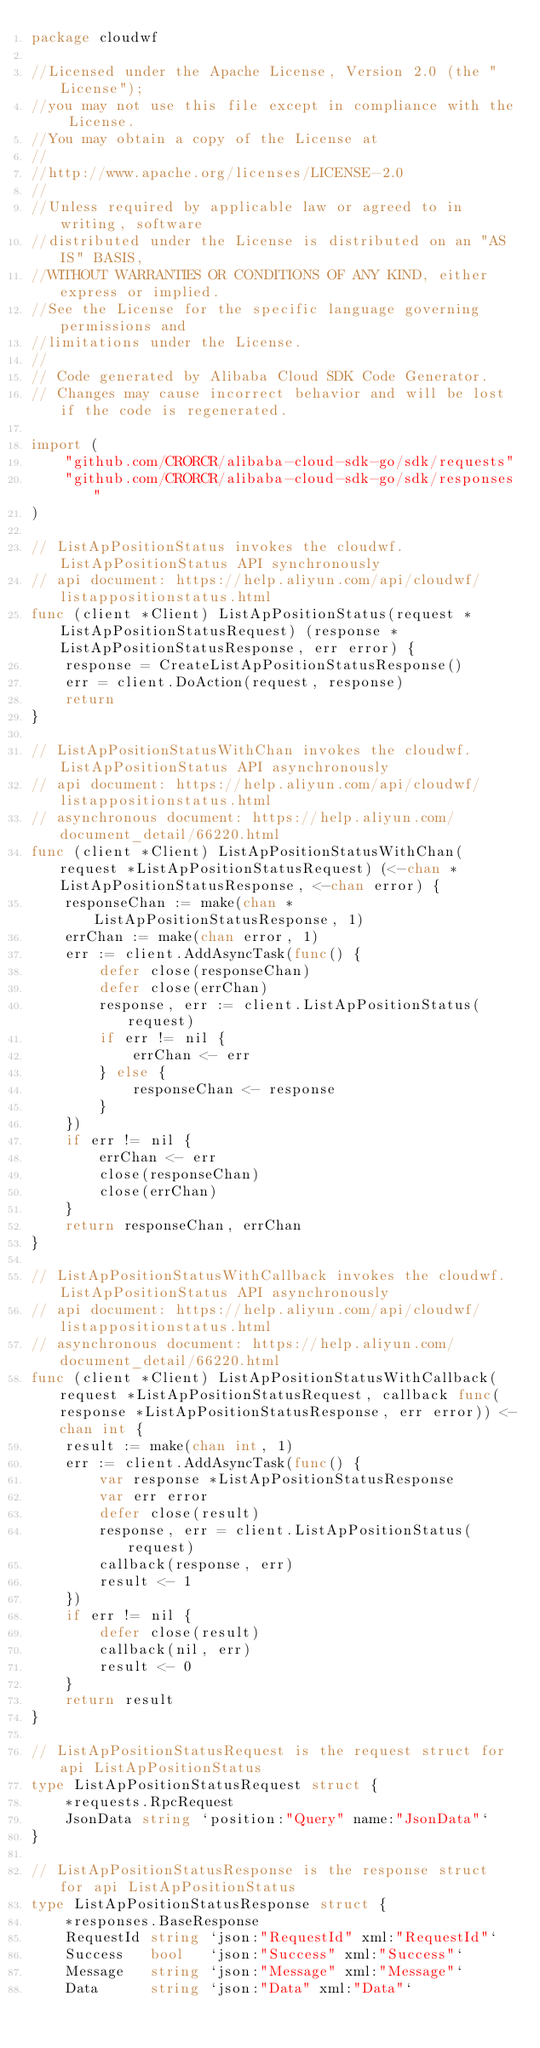<code> <loc_0><loc_0><loc_500><loc_500><_Go_>package cloudwf

//Licensed under the Apache License, Version 2.0 (the "License");
//you may not use this file except in compliance with the License.
//You may obtain a copy of the License at
//
//http://www.apache.org/licenses/LICENSE-2.0
//
//Unless required by applicable law or agreed to in writing, software
//distributed under the License is distributed on an "AS IS" BASIS,
//WITHOUT WARRANTIES OR CONDITIONS OF ANY KIND, either express or implied.
//See the License for the specific language governing permissions and
//limitations under the License.
//
// Code generated by Alibaba Cloud SDK Code Generator.
// Changes may cause incorrect behavior and will be lost if the code is regenerated.

import (
	"github.com/CRORCR/alibaba-cloud-sdk-go/sdk/requests"
	"github.com/CRORCR/alibaba-cloud-sdk-go/sdk/responses"
)

// ListApPositionStatus invokes the cloudwf.ListApPositionStatus API synchronously
// api document: https://help.aliyun.com/api/cloudwf/listappositionstatus.html
func (client *Client) ListApPositionStatus(request *ListApPositionStatusRequest) (response *ListApPositionStatusResponse, err error) {
	response = CreateListApPositionStatusResponse()
	err = client.DoAction(request, response)
	return
}

// ListApPositionStatusWithChan invokes the cloudwf.ListApPositionStatus API asynchronously
// api document: https://help.aliyun.com/api/cloudwf/listappositionstatus.html
// asynchronous document: https://help.aliyun.com/document_detail/66220.html
func (client *Client) ListApPositionStatusWithChan(request *ListApPositionStatusRequest) (<-chan *ListApPositionStatusResponse, <-chan error) {
	responseChan := make(chan *ListApPositionStatusResponse, 1)
	errChan := make(chan error, 1)
	err := client.AddAsyncTask(func() {
		defer close(responseChan)
		defer close(errChan)
		response, err := client.ListApPositionStatus(request)
		if err != nil {
			errChan <- err
		} else {
			responseChan <- response
		}
	})
	if err != nil {
		errChan <- err
		close(responseChan)
		close(errChan)
	}
	return responseChan, errChan
}

// ListApPositionStatusWithCallback invokes the cloudwf.ListApPositionStatus API asynchronously
// api document: https://help.aliyun.com/api/cloudwf/listappositionstatus.html
// asynchronous document: https://help.aliyun.com/document_detail/66220.html
func (client *Client) ListApPositionStatusWithCallback(request *ListApPositionStatusRequest, callback func(response *ListApPositionStatusResponse, err error)) <-chan int {
	result := make(chan int, 1)
	err := client.AddAsyncTask(func() {
		var response *ListApPositionStatusResponse
		var err error
		defer close(result)
		response, err = client.ListApPositionStatus(request)
		callback(response, err)
		result <- 1
	})
	if err != nil {
		defer close(result)
		callback(nil, err)
		result <- 0
	}
	return result
}

// ListApPositionStatusRequest is the request struct for api ListApPositionStatus
type ListApPositionStatusRequest struct {
	*requests.RpcRequest
	JsonData string `position:"Query" name:"JsonData"`
}

// ListApPositionStatusResponse is the response struct for api ListApPositionStatus
type ListApPositionStatusResponse struct {
	*responses.BaseResponse
	RequestId string `json:"RequestId" xml:"RequestId"`
	Success   bool   `json:"Success" xml:"Success"`
	Message   string `json:"Message" xml:"Message"`
	Data      string `json:"Data" xml:"Data"`</code> 